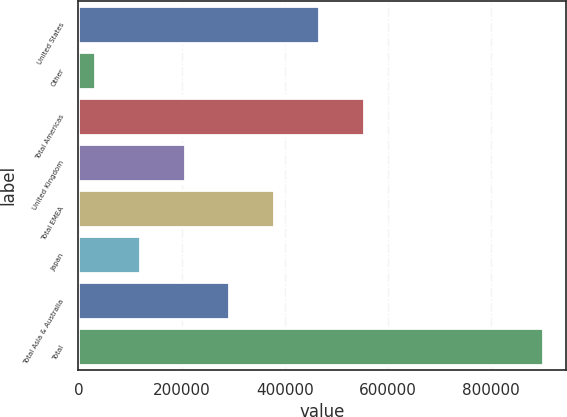<chart> <loc_0><loc_0><loc_500><loc_500><bar_chart><fcel>United States<fcel>Other<fcel>Total Americas<fcel>United Kingdom<fcel>Total EMEA<fcel>Japan<fcel>Total Asia & Australia<fcel>Total<nl><fcel>466564<fcel>32188<fcel>553440<fcel>205939<fcel>379689<fcel>119063<fcel>292814<fcel>900941<nl></chart> 